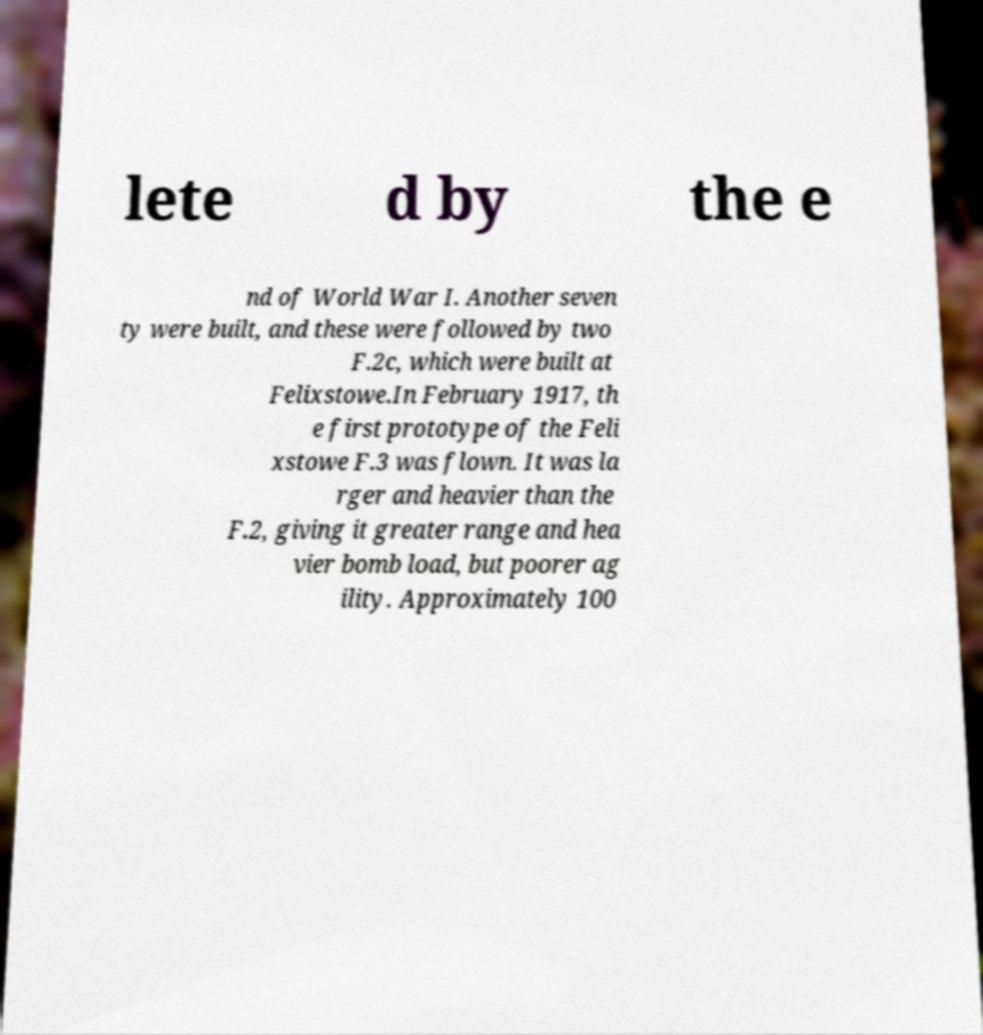Can you read and provide the text displayed in the image?This photo seems to have some interesting text. Can you extract and type it out for me? lete d by the e nd of World War I. Another seven ty were built, and these were followed by two F.2c, which were built at Felixstowe.In February 1917, th e first prototype of the Feli xstowe F.3 was flown. It was la rger and heavier than the F.2, giving it greater range and hea vier bomb load, but poorer ag ility. Approximately 100 